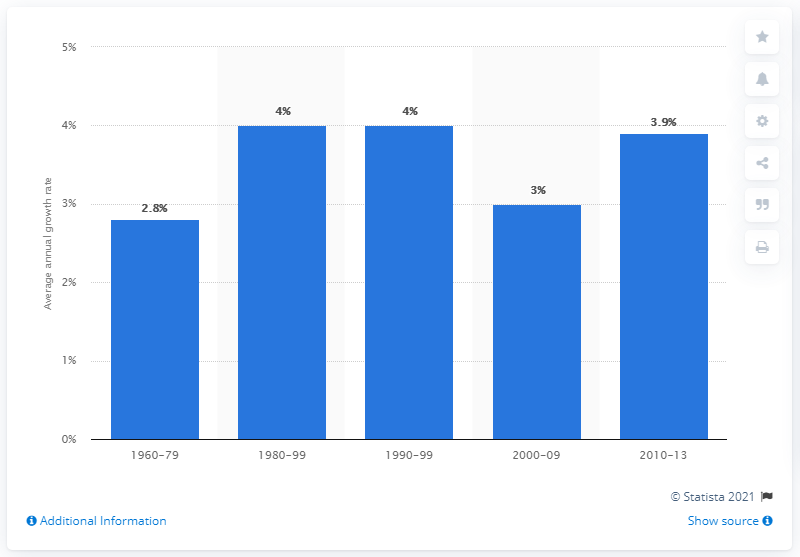Mention a couple of crucial points in this snapshot. The manufacturing sector's labor productivity increased at an annual rate of 3.9% from 2010 to 2013. 